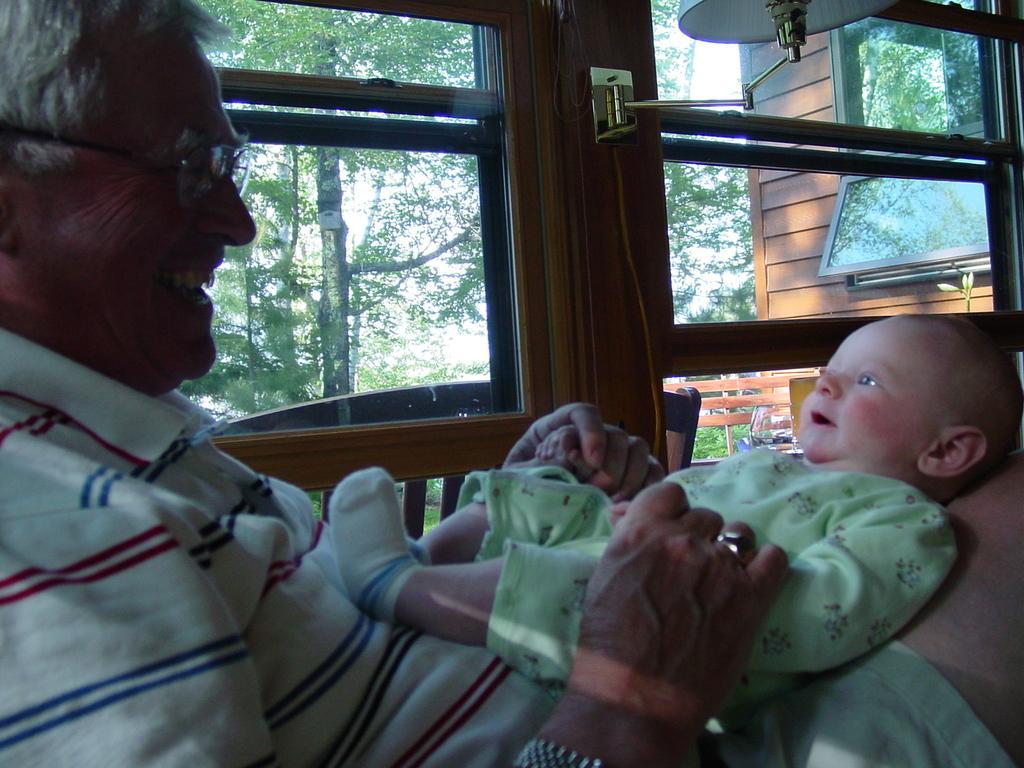Can you describe this image briefly? In this image we can see a man wearing specs. And he is holding a baby on the lap. In the back there are windows. Through the windows we can see trees. On the wall there is a lamp. 